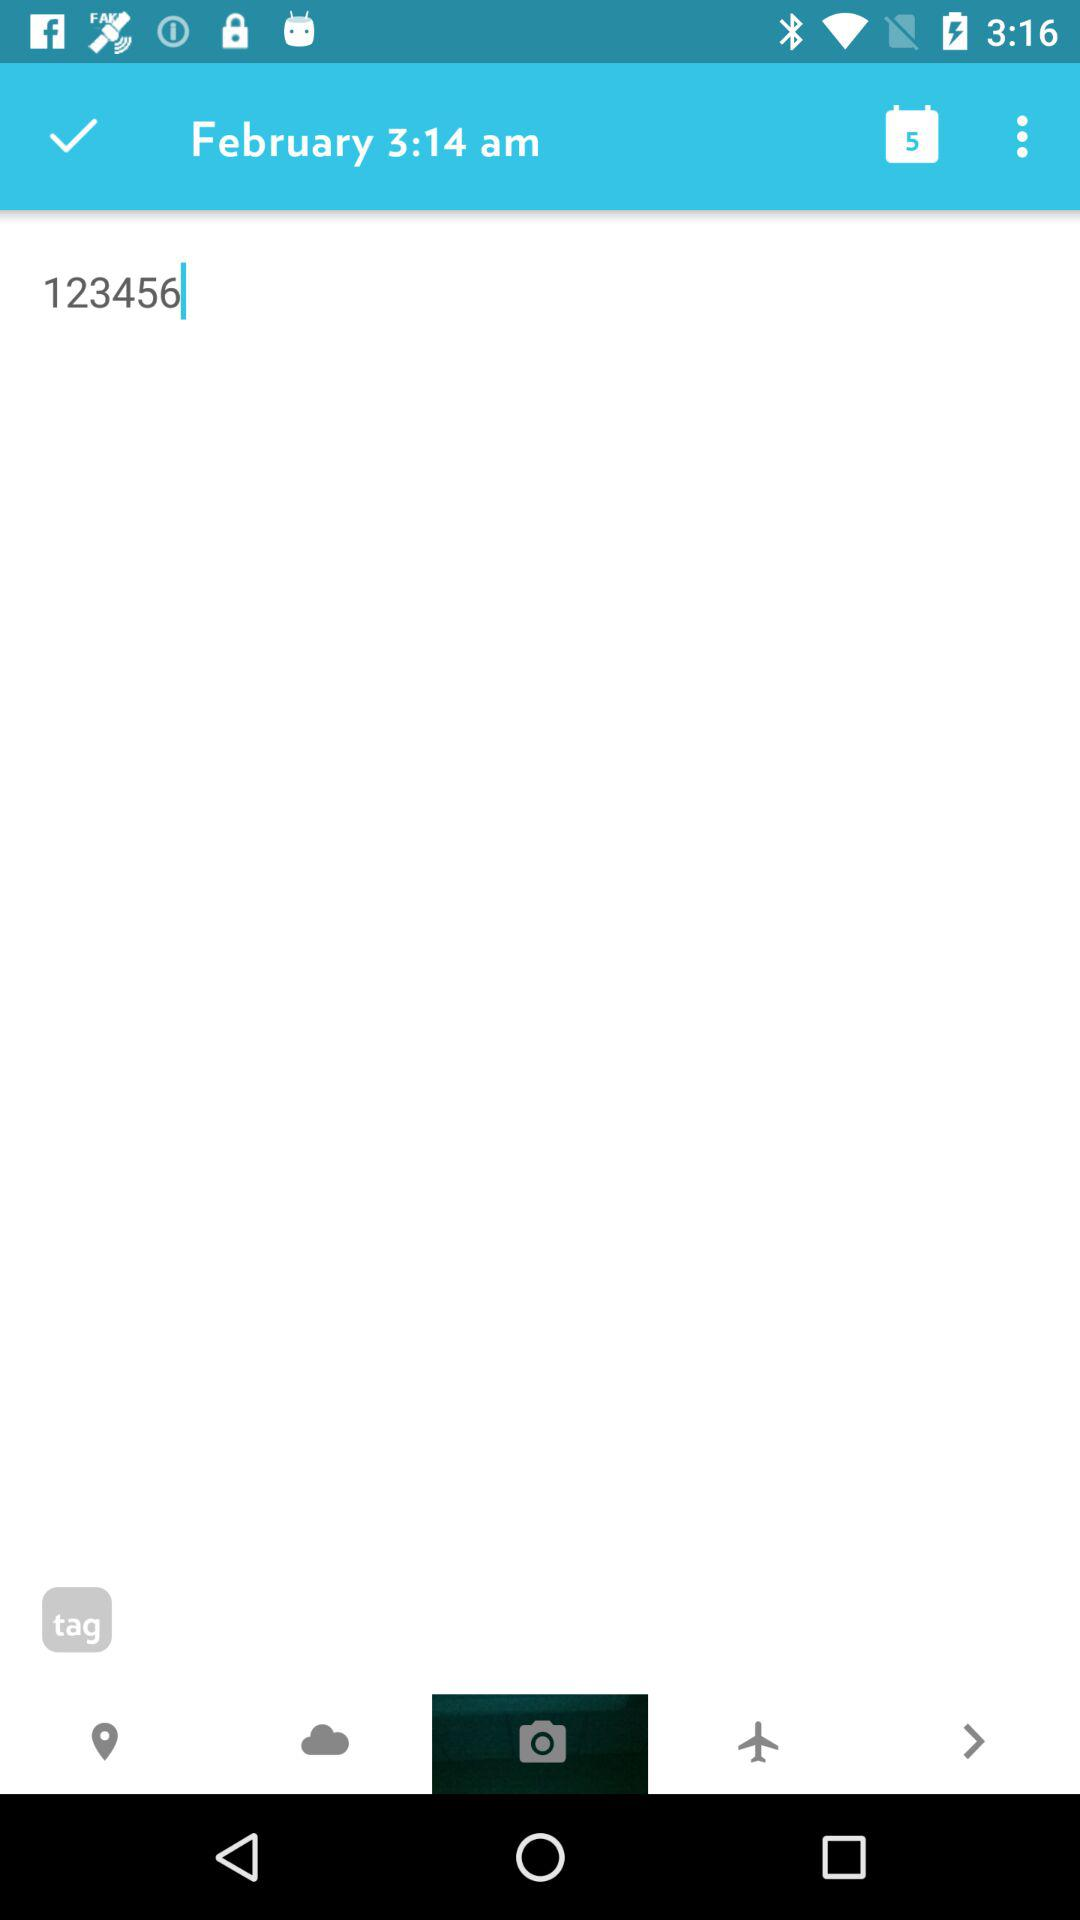What is the number? The number is 123456. 